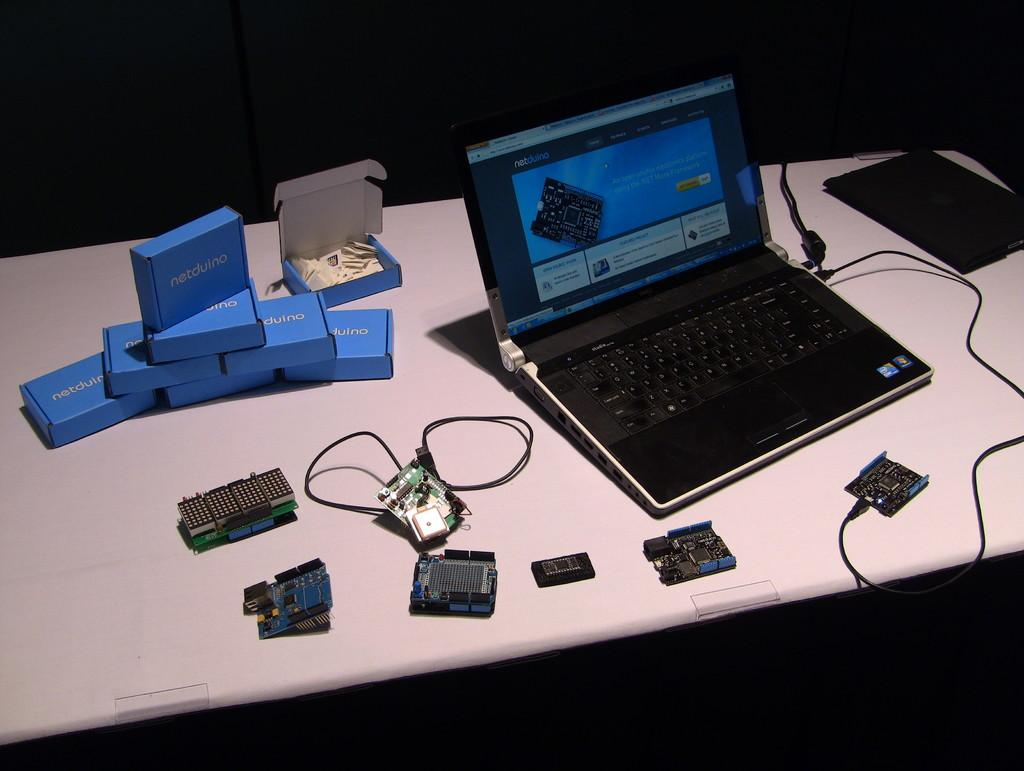<image>
Describe the image concisely. Netduino parts are sitting on a table with a laptop. 